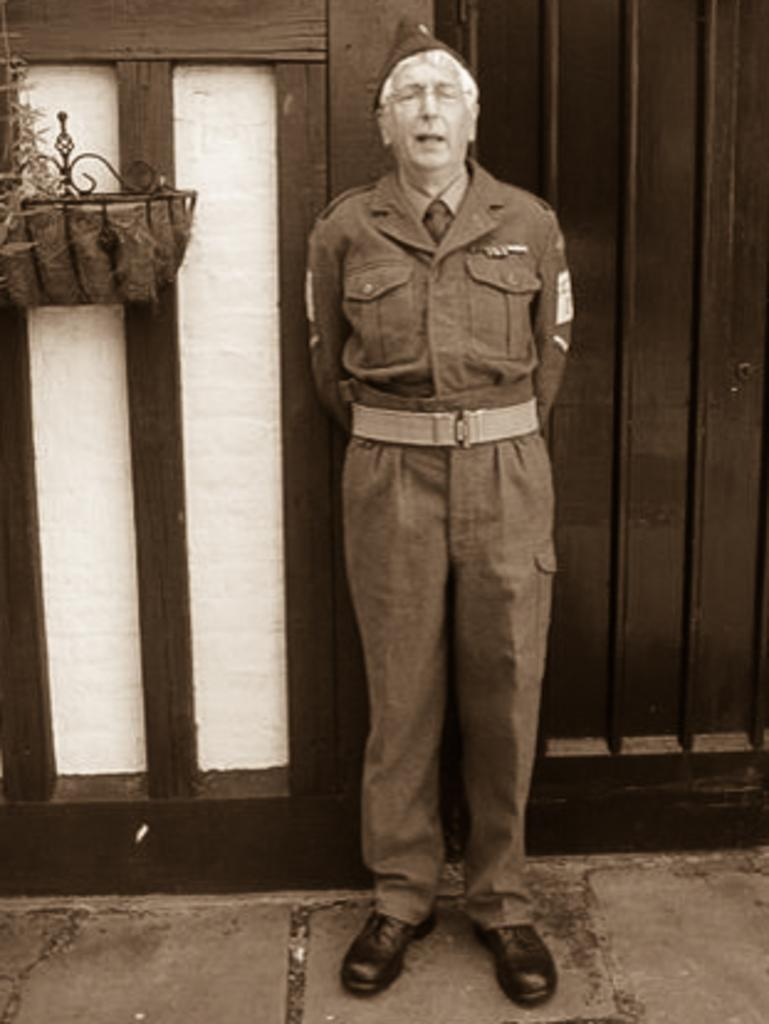Who is present in the image? There is a man in the image. What is the man wearing on his head? The man is wearing a cap. What type of structures can be seen in the image? There are houses in the image. Where is the man standing in the image? The man is standing on a path. What can be seen in the background of the image? There is a window, a grill, and a flower pot in the background of the image. What thought is the man writing down in his notebook in the image? There is no notebook present in the image, and therefore no thoughts can be observed being written down. 